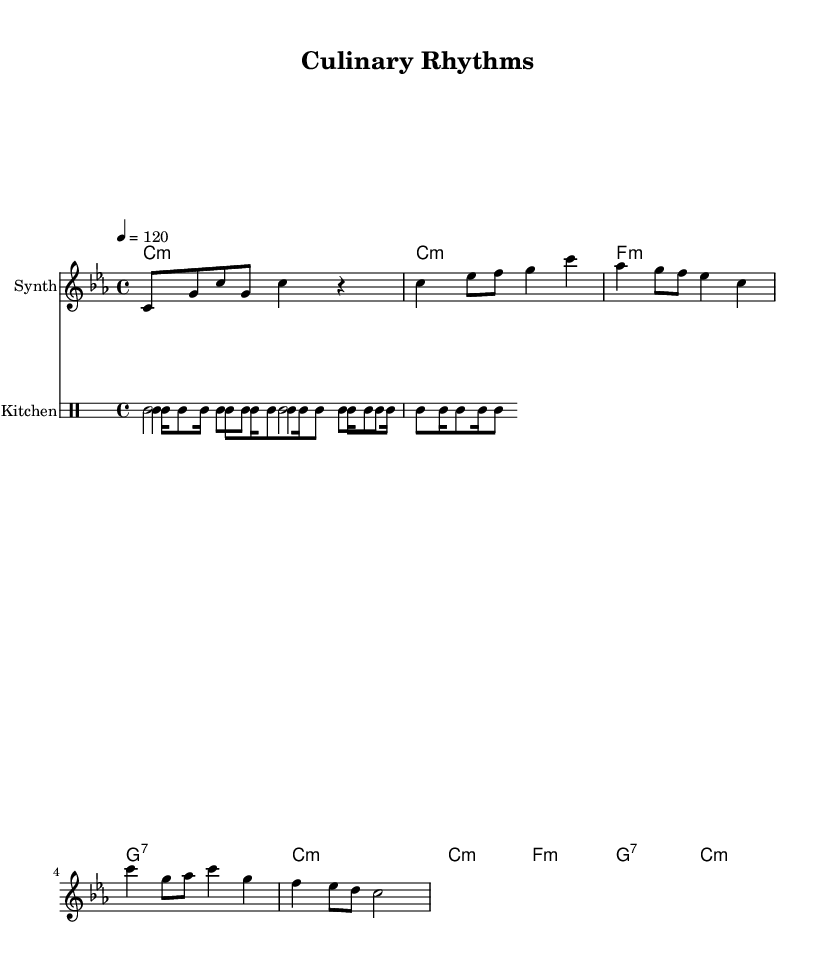What is the key signature of this music? The key signature is C minor, which has three flats: B flat, E flat, and A flat.
Answer: C minor What is the time signature of this music? The time signature is indicated at the beginning of the score, showing that there are four beats in each measure with a quarter note receiving one beat.
Answer: 4/4 What is the tempo marking for this piece? The tempo marking indicates that the piece should be played at a speed of 120 beats per minute, which provides a moderate tempo for electronic music.
Answer: 120 How many measures are in the chorus section? By examining the numbered bars from the score, we can count the three measures that comprise the chorus segment, which are structurally different from the verse.
Answer: 3 What types of kitchen utensils are used in the percussion? The percussion section utilizes three different kitchen utensils, demonstrating a creative blend of sounds: a whisk, a spoon, and a pot, each contributing unique timbres.
Answer: Whisk, Spoon, Pot What is the first chord played in the piece? The chord played at the start of the piece is labeled as a C minor chord, which sets the tonal center for the composition.
Answer: C minor What is the rhythmic pattern of the spoon part? The rhythmic pattern for the spoon represents a bass drum pattern, consisting of a combination of quarter notes followed by eighth notes creating a steady beat.
Answer: Bass drum 